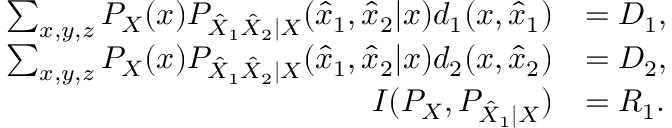Convert formula to latex. <formula><loc_0><loc_0><loc_500><loc_500>\begin{array} { r l } { \sum _ { x , y , z } P _ { X } ( x ) P _ { \hat { X } _ { 1 } \hat { X } _ { 2 } | X } ( \hat { x } _ { 1 } , \hat { x } _ { 2 } | x ) d _ { 1 } ( x , \hat { x } _ { 1 } ) } & { = D _ { 1 } , } \\ { \sum _ { x , y , z } P _ { X } ( x ) P _ { \hat { X } _ { 1 } \hat { X } _ { 2 } | X } ( \hat { x } _ { 1 } , \hat { x } _ { 2 } | x ) d _ { 2 } ( x , \hat { x } _ { 2 } ) } & { = D _ { 2 } , } \\ { I ( P _ { X } , P _ { \hat { X } _ { 1 } | X } ) } & { = R _ { 1 } . } \end{array}</formula> 